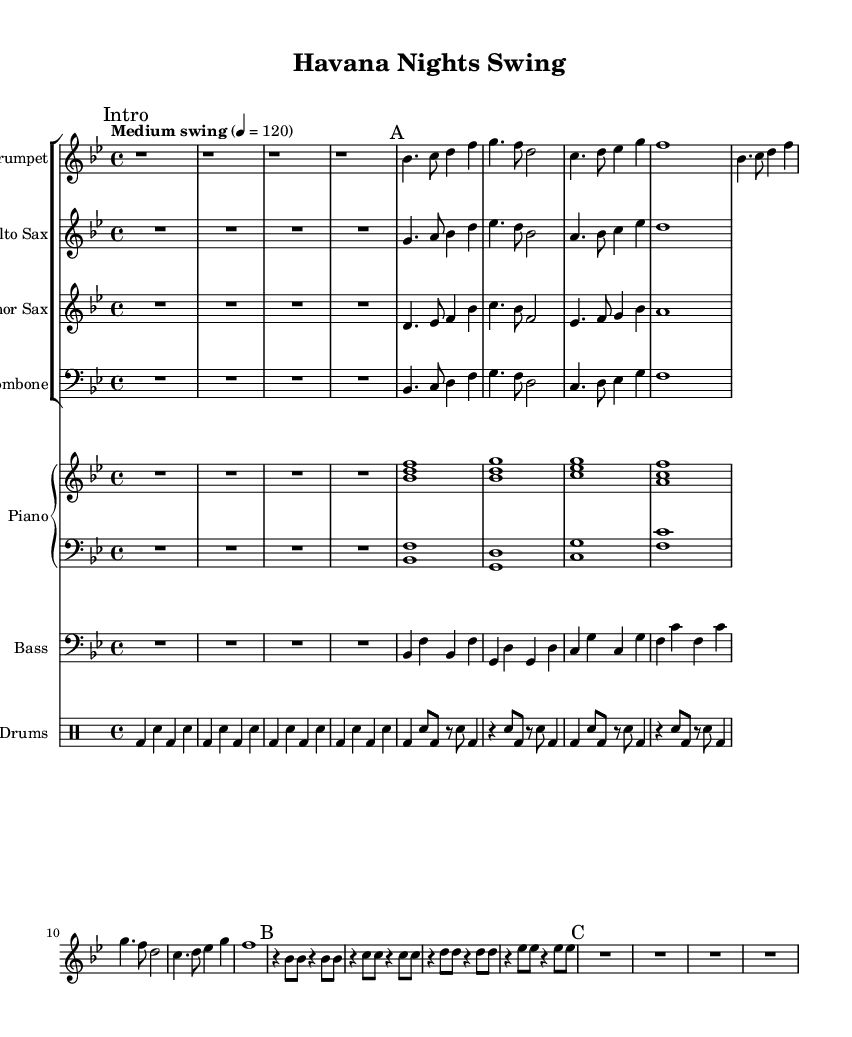What is the key signature of this music? The key signature is B flat major, which has two flats: B flat and E flat. This is indicated by the key signature at the beginning of the staff.
Answer: B flat major What is the time signature of this music? The time signature is 4/4, which means there are four beats in a measure and the quarter note receives one beat. This is shown at the beginning of the score.
Answer: 4/4 What is the tempo marking indicated in the music? The tempo marking is "Medium swing" with a metronome marking of 120 beats per minute. This sets the pace for the performance.
Answer: Medium swing 4 = 120 How many measures are in section A? Section A contains 4 measures, which can be counted from the beginning of the section until before the next section (B) starts.
Answer: 4 Which instrument has the highest pitch in the first section (A)? The trumpet has the highest pitch in section A, where it plays notes starting from B flat and ascending. This can be identified by looking at the note heads on the staff.
Answer: Trumpet In section B, which note is sustained for the full duration of the measure? In section B, the note B flat is sustained for the full duration of the measure, as indicated by the whole note symbol in the music.
Answer: B flat Are there any rhythmic patterns that suggest a Latin influence in the drum part? Yes, the drum part features consistent use of syncopated rhythms, typical in Latin jazz, with the bass drum and snare playing in a pattern that emphasizes off-beats. This is characterized by the specific beats where the snare alternates with the bass drum.
Answer: Yes, syncopation 